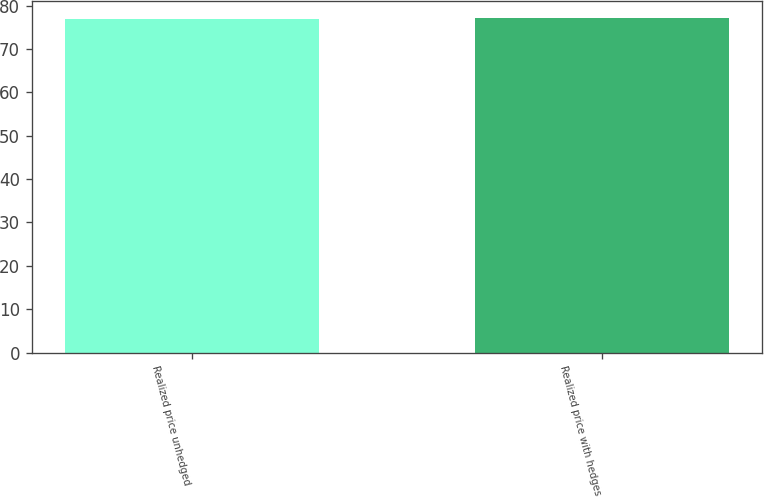Convert chart. <chart><loc_0><loc_0><loc_500><loc_500><bar_chart><fcel>Realized price unhedged<fcel>Realized price with hedges<nl><fcel>77<fcel>77.1<nl></chart> 